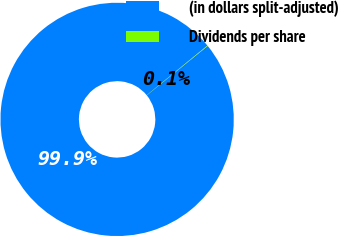Convert chart. <chart><loc_0><loc_0><loc_500><loc_500><pie_chart><fcel>(in dollars split-adjusted)<fcel>Dividends per share<nl><fcel>99.94%<fcel>0.06%<nl></chart> 